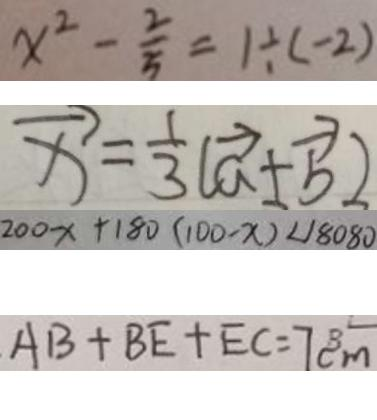<formula> <loc_0><loc_0><loc_500><loc_500>x ^ { 2 } - \frac { 2 } { 5 } = 1 \div ( - 2 ) 
 \overrightarrow { x } = \frac { 1 } { 3 } ( \overrightarrow { a } + \overrightarrow { b } ) 
 2 0 0 x + 1 8 0 ( 1 0 0 - x ) < 1 8 0 8 0 
 A B + B E + E C = 7 c m</formula> 